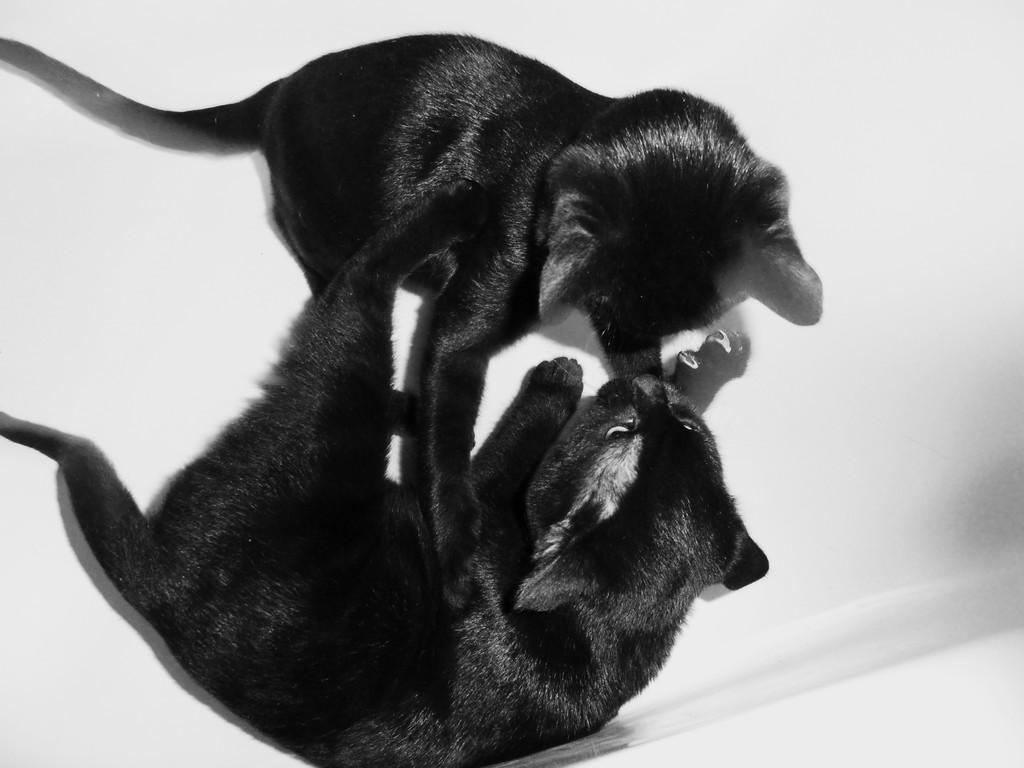How many cats are in the image? There are two cats in the image. What color are the cats? The cats are black in color. What is the color of the surface the cats are on? The cats are on a white colored surface. Are there any magic spells being cast by the cats in the image? There is no indication of magic spells or any magical elements in the image; it simply features two black cats on a white surface. 